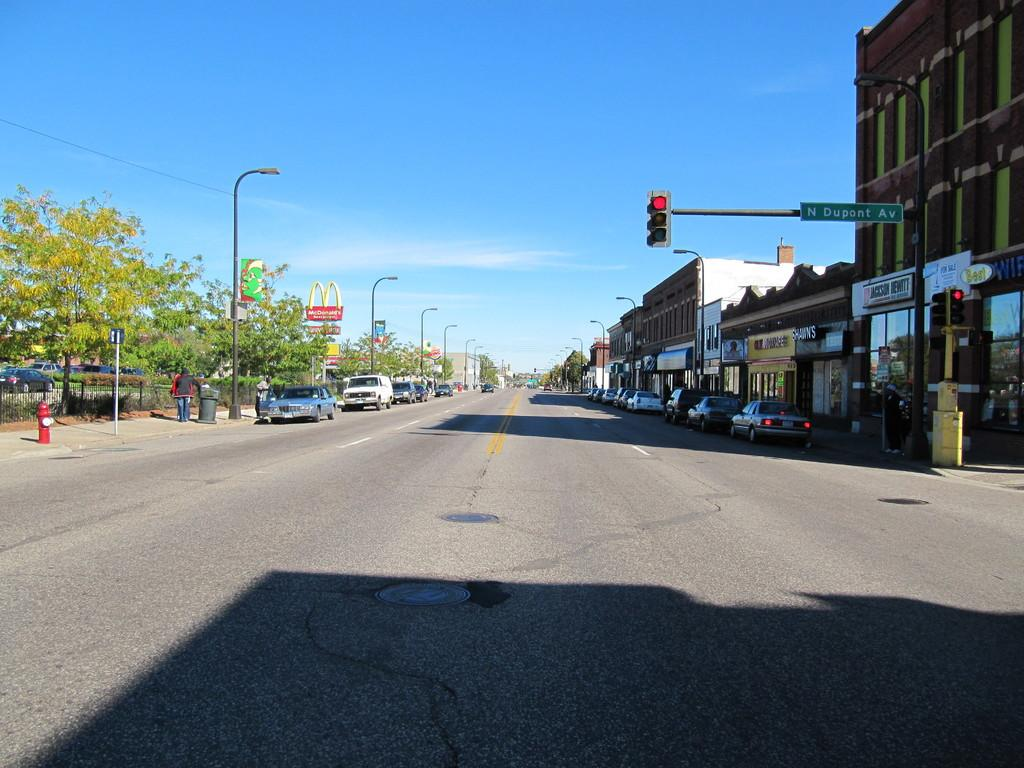<image>
Write a terse but informative summary of the picture. Shawn's is to the left of Jackson Hewitt. 